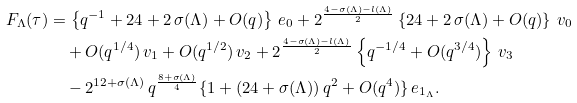<formula> <loc_0><loc_0><loc_500><loc_500>F _ { \Lambda } ( \tau ) & = \left \{ q ^ { - 1 } + 2 4 + 2 \, \sigma ( \Lambda ) + O ( q ) \right \} \, { e } _ { 0 } + 2 ^ { \frac { 4 - \sigma ( \Lambda ) - l ( \Lambda ) } { 2 } } \left \{ 2 4 + 2 \, \sigma ( \Lambda ) + O ( q ) \right \} \, { v } _ { 0 } \\ & \quad + O ( q ^ { 1 / 4 } ) \, { v } _ { 1 } + O ( q ^ { 1 / 2 } ) \, { v } _ { 2 } + 2 ^ { \frac { 4 - \sigma ( \Lambda ) - l ( \Lambda ) } { 2 } } \left \{ q ^ { - 1 / 4 } + O ( q ^ { 3 / 4 } ) \right \} \, { v } _ { 3 } \\ & \quad - 2 ^ { 1 2 + \sigma ( \Lambda ) } \, q ^ { \frac { 8 + \sigma ( \Lambda ) } { 4 } } \{ 1 + ( 2 4 + \sigma ( \Lambda ) ) \, q ^ { 2 } + O ( q ^ { 4 } ) \} \, { e } _ { { 1 } _ { \Lambda } } .</formula> 